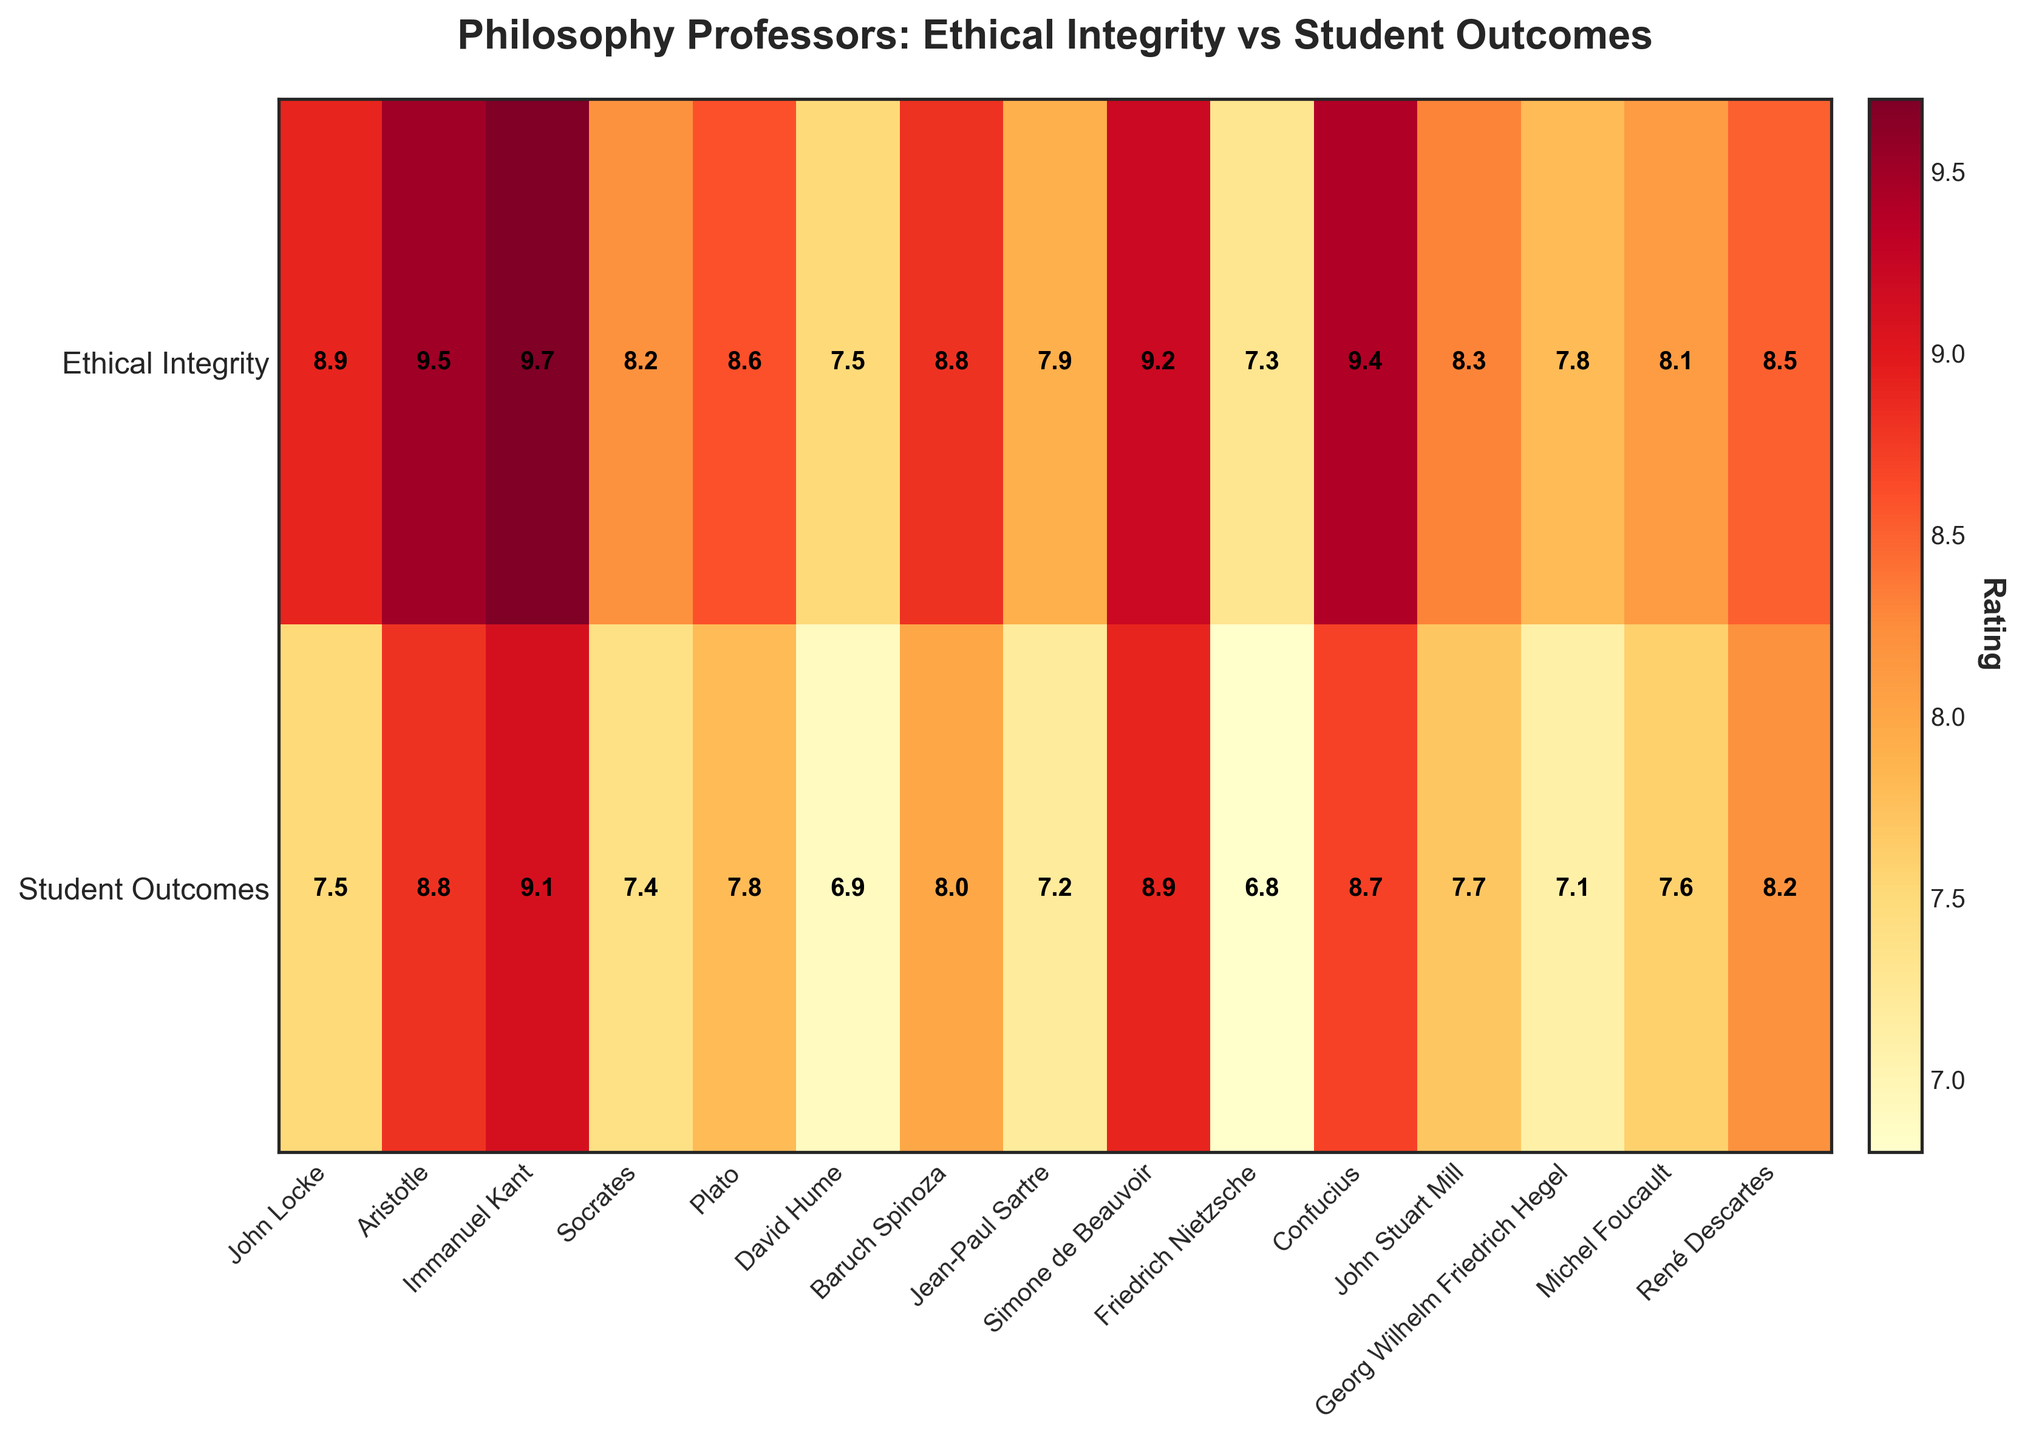What is the title of the heatmap? The title is usually located at the top of the figure. Here it reads "Philosophy Professors: Ethical Integrity vs Student Outcomes".
Answer: Philosophy Professors: Ethical Integrity vs Student Outcomes Which professor has the highest Ethical Integrity rating? The heatmap displays the Ethical Integrity ratings along one axis. You need to find the highest value in the row labeled "Ethical Integrity". Immanuel Kant has a rating of 9.7, which is the highest.
Answer: Immanuel Kant Who has a higher Student Outcomes rating, Plato or Baruch Spinoza? To determine who has a higher rating, compare the values in the "Student Outcomes" row for Plato and Baruch Spinoza. Plato has a rating of 7.8, while Baruch Spinoza has a rating of 8.0.
Answer: Baruch Spinoza What is the average Ethical Integrity rating of all professors? To find the average, sum all the Ethical Integrity ratings, then divide by the number of professors. Sum = 8.9 + 9.5 + 9.7 + 8.2 + 8.6 + 7.5 + 8.8 + 7.9 + 9.2 + 7.3 + 9.4 + 8.3 + 7.8 + 8.1 + 8.5 = 138.7. Now, divide by 15 (number of professors) to get the average: 138.7/15 = 9.25.
Answer: 9.25 Which professor has the lowest Student Outcomes rating? Check the values in the "Student Outcomes" row and find the lowest one. Friedrich Nietzsche has the lowest rating of 6.8.
Answer: Friedrich Nietzsche How does the Ethical Integrity rating of Socrates compare with his Student Outcomes rating? Compare the two values for Socrates in each row. Socrates has an Ethical Integrity rating of 8.2 and a Student Outcomes rating of 7.4, indicating his Ethical Integrity rating is higher.
Answer: Higher What is the difference between the highest and lowest Ethical Integrity ratings? Find the highest and lowest values in the "Ethical Integrity" row and calculate their difference. Highest is 9.7 (Immanuel Kant), and lowest is 7.3 (Friedrich Nietzsche). Difference = 9.7 - 7.3 = 2.4.
Answer: 2.4 Does John Locke have a higher rating in Ethical Integrity or Student Outcomes? For John Locke, compare the values in both rows. Ethical Integrity rating is 8.9, and Student Outcomes rating is 7.5. Ethical Integrity is higher.
Answer: Ethical Integrity Which two professors have the closest ratings in Student Outcomes? Compare all the values in the "Student Outcomes" row and find the smallest difference. John Locke (7.5) and Socrates (7.4) have the closest ratings with a difference of 0.1.
Answer: John Locke and Socrates How many professors have an Ethical Integrity rating above 9? Count the number of professors with values greater than 9 in the "Ethical Integrity" row: Aristotle (9.5), Immanuel Kan (9.7), Simone de Beauvoir (9.2), Confucius (9.4). There are 4 professors.
Answer: 4 